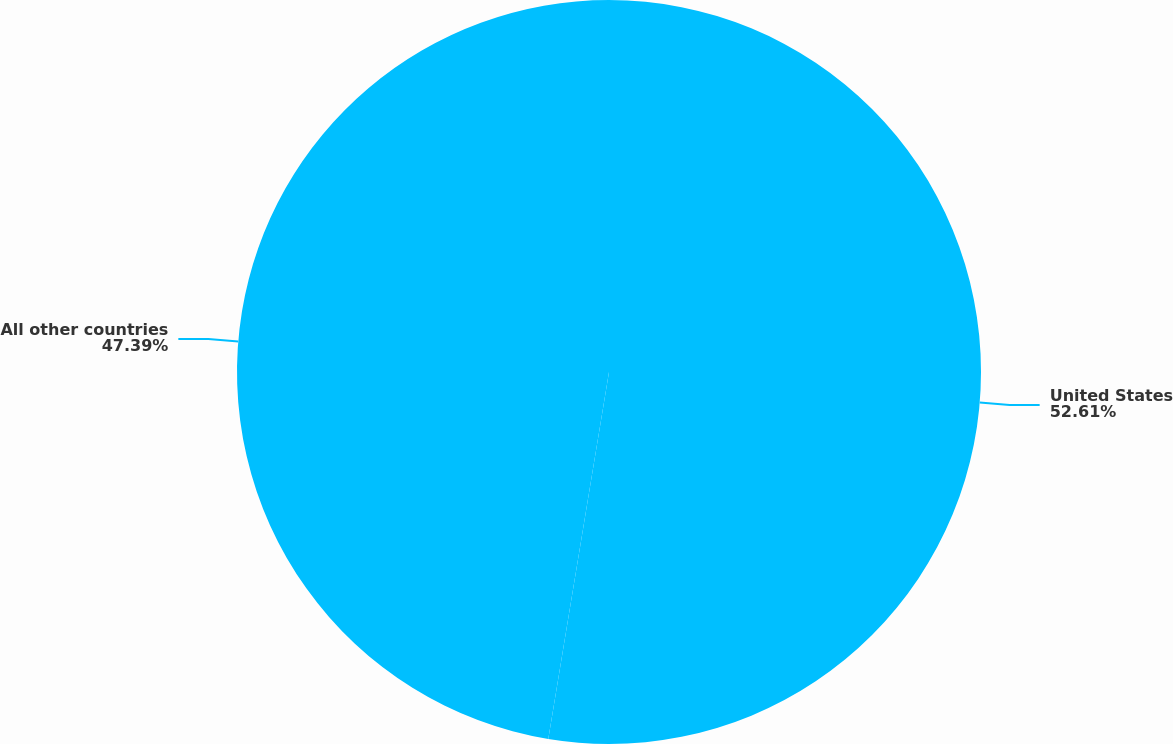Convert chart to OTSL. <chart><loc_0><loc_0><loc_500><loc_500><pie_chart><fcel>United States<fcel>All other countries<nl><fcel>52.61%<fcel>47.39%<nl></chart> 